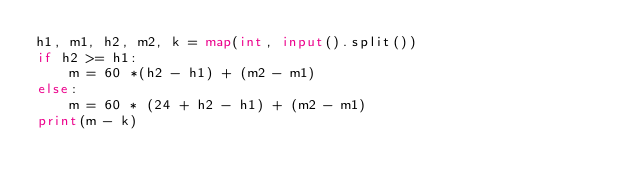<code> <loc_0><loc_0><loc_500><loc_500><_Python_>h1, m1, h2, m2, k = map(int, input().split())
if h2 >= h1:
    m = 60 *(h2 - h1) + (m2 - m1)
else:
    m = 60 * (24 + h2 - h1) + (m2 - m1)
print(m - k)
</code> 